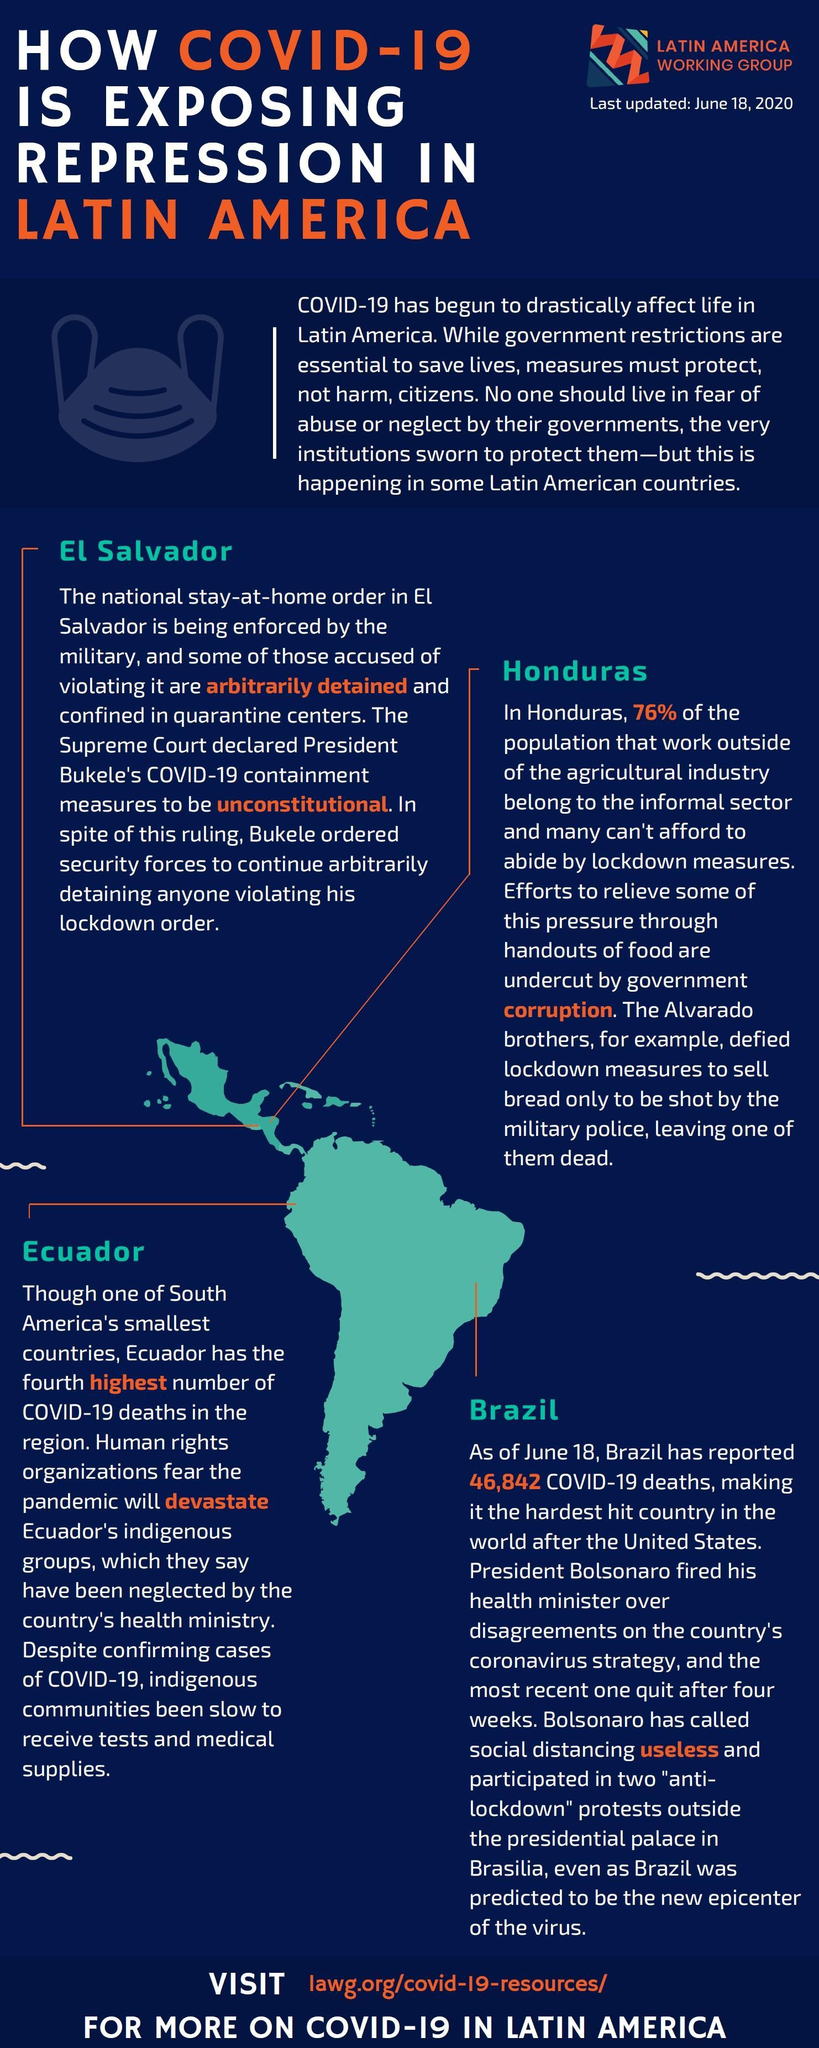How many Latin American countries are mentioned?
Answer the question with a short phrase. 4 